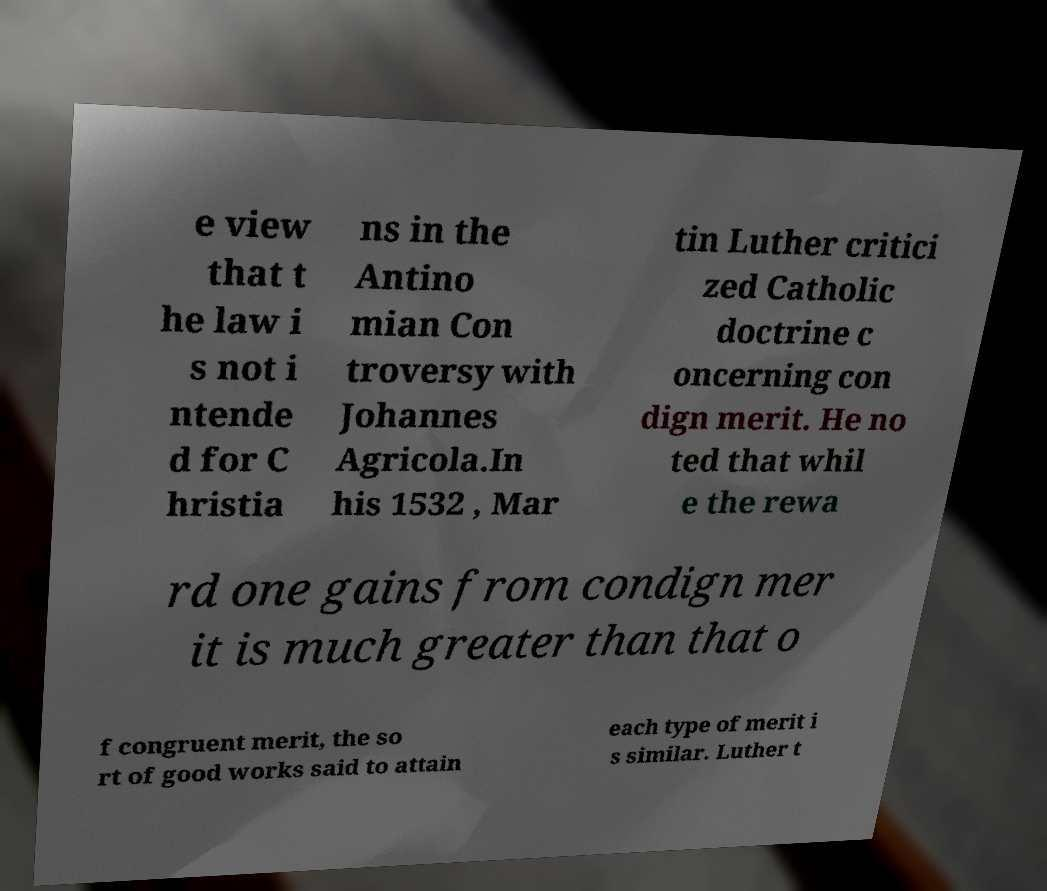Can you accurately transcribe the text from the provided image for me? e view that t he law i s not i ntende d for C hristia ns in the Antino mian Con troversy with Johannes Agricola.In his 1532 , Mar tin Luther critici zed Catholic doctrine c oncerning con dign merit. He no ted that whil e the rewa rd one gains from condign mer it is much greater than that o f congruent merit, the so rt of good works said to attain each type of merit i s similar. Luther t 